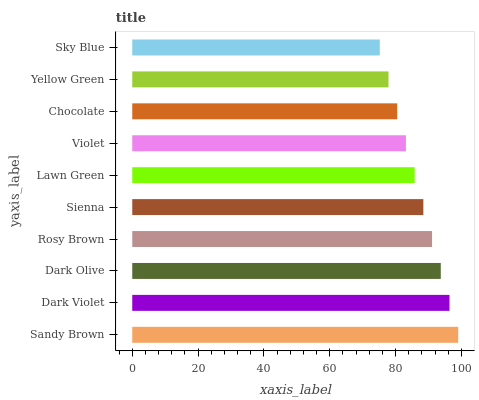Is Sky Blue the minimum?
Answer yes or no. Yes. Is Sandy Brown the maximum?
Answer yes or no. Yes. Is Dark Violet the minimum?
Answer yes or no. No. Is Dark Violet the maximum?
Answer yes or no. No. Is Sandy Brown greater than Dark Violet?
Answer yes or no. Yes. Is Dark Violet less than Sandy Brown?
Answer yes or no. Yes. Is Dark Violet greater than Sandy Brown?
Answer yes or no. No. Is Sandy Brown less than Dark Violet?
Answer yes or no. No. Is Sienna the high median?
Answer yes or no. Yes. Is Lawn Green the low median?
Answer yes or no. Yes. Is Violet the high median?
Answer yes or no. No. Is Chocolate the low median?
Answer yes or no. No. 